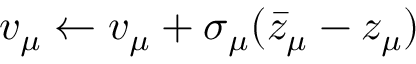<formula> <loc_0><loc_0><loc_500><loc_500>v _ { \mu } \leftarrow v _ { \mu } + \sigma _ { \mu } ( \bar { z } _ { \mu } - z _ { \mu } )</formula> 